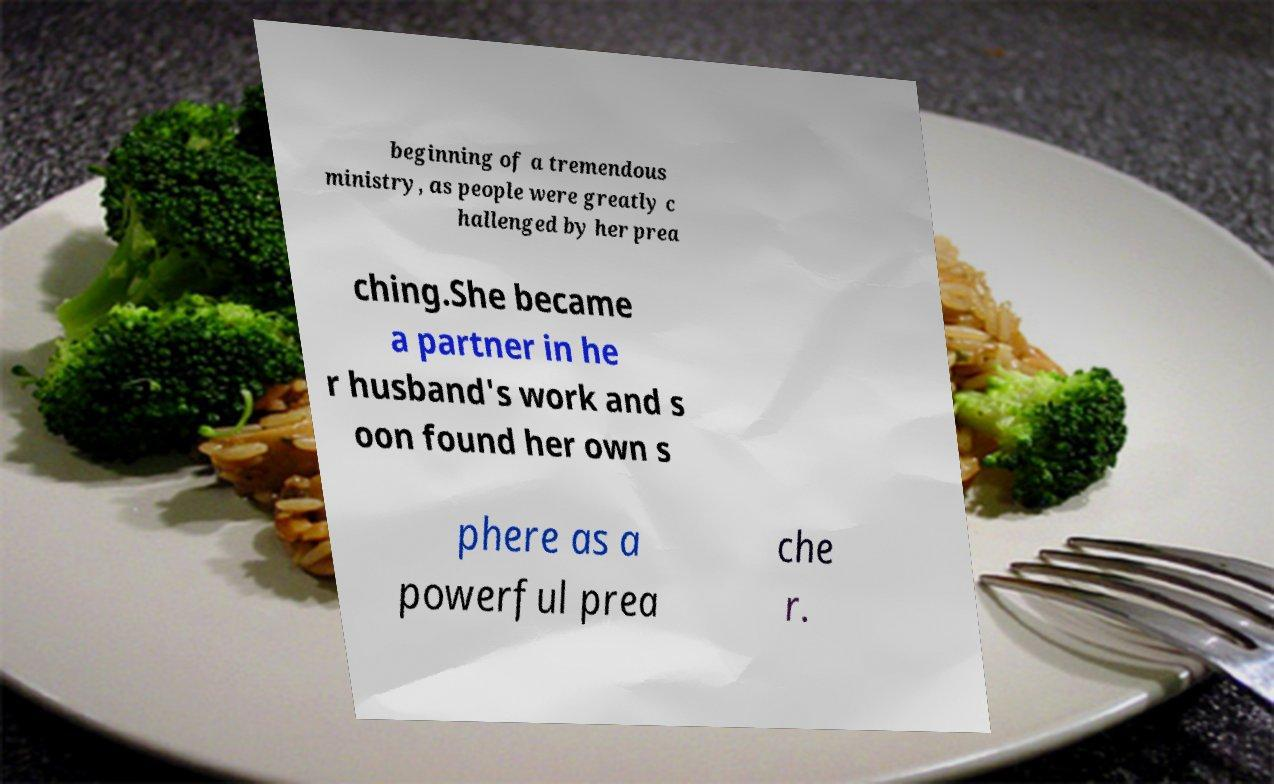I need the written content from this picture converted into text. Can you do that? beginning of a tremendous ministry, as people were greatly c hallenged by her prea ching.She became a partner in he r husband's work and s oon found her own s phere as a powerful prea che r. 